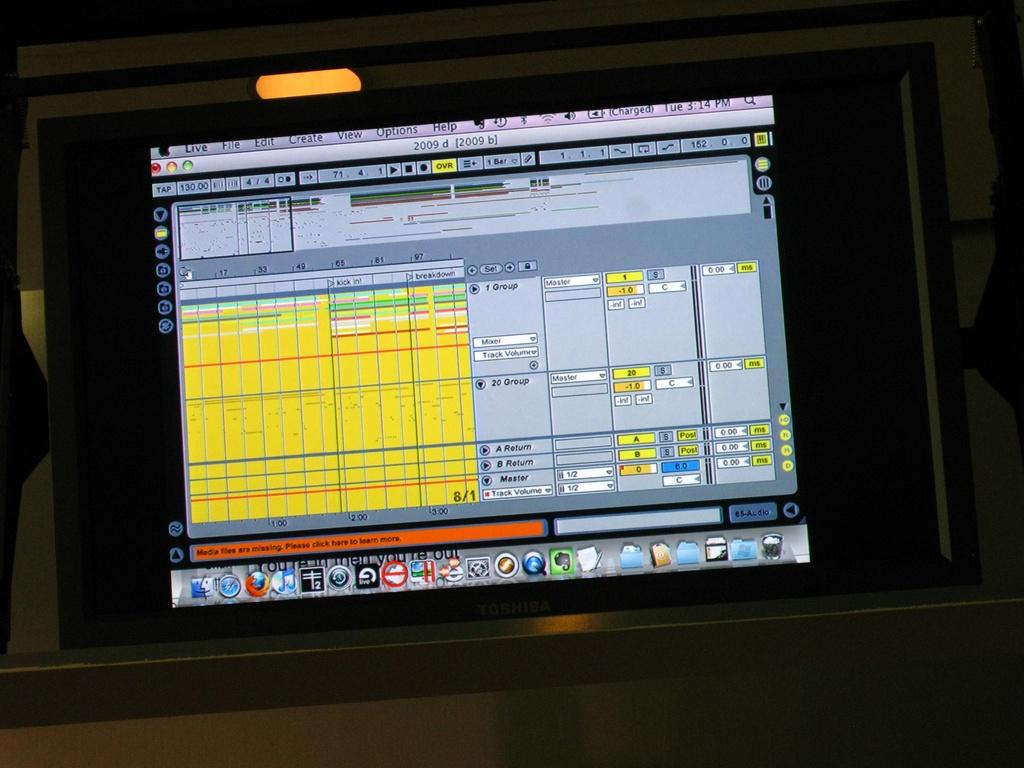<image>
Render a clear and concise summary of the photo. a computer monitor open to a screen with words Media files are missing 